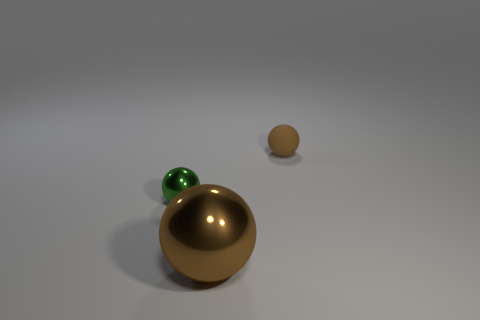What is the material of the small object that is the same color as the big metallic ball?
Your answer should be very brief. Rubber. Is there a large metallic sphere of the same color as the matte sphere?
Your answer should be compact. Yes. Is there any other thing that is the same size as the brown metallic thing?
Offer a terse response. No. Is the number of tiny matte balls less than the number of balls?
Ensure brevity in your answer.  Yes. What number of metallic objects are small things or large spheres?
Your answer should be very brief. 2. There is a brown thing in front of the tiny matte sphere; is there a tiny thing to the right of it?
Provide a succinct answer. Yes. Are the brown object in front of the small matte object and the green thing made of the same material?
Keep it short and to the point. Yes. How many other objects are there of the same color as the matte sphere?
Your response must be concise. 1. Do the big thing and the matte ball have the same color?
Offer a terse response. Yes. There is a brown object left of the thing that is on the right side of the large metallic ball; how big is it?
Your answer should be compact. Large. 